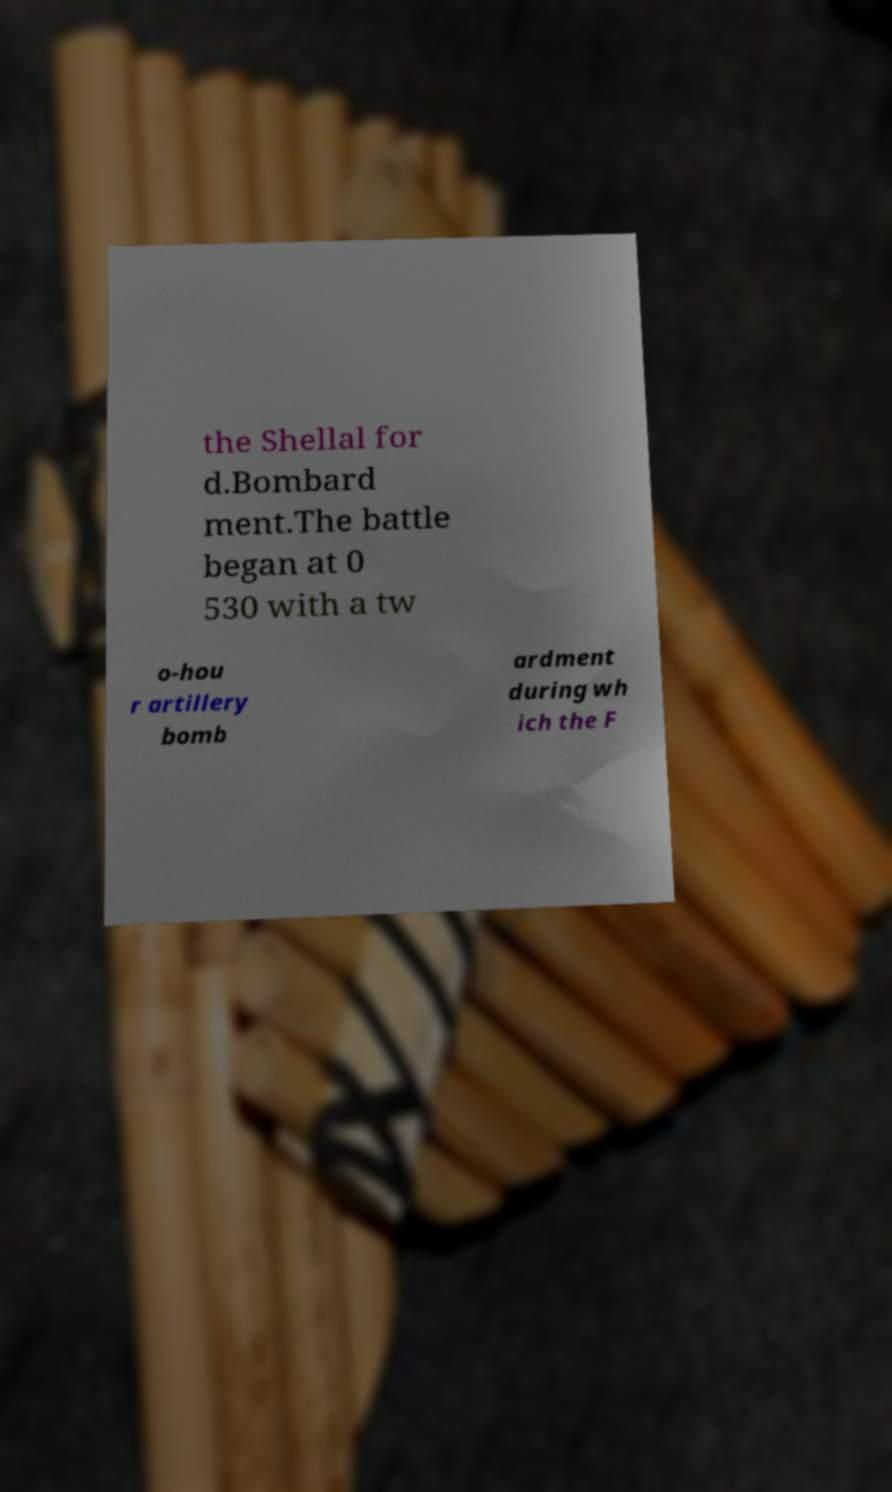Could you assist in decoding the text presented in this image and type it out clearly? the Shellal for d.Bombard ment.The battle began at 0 530 with a tw o-hou r artillery bomb ardment during wh ich the F 